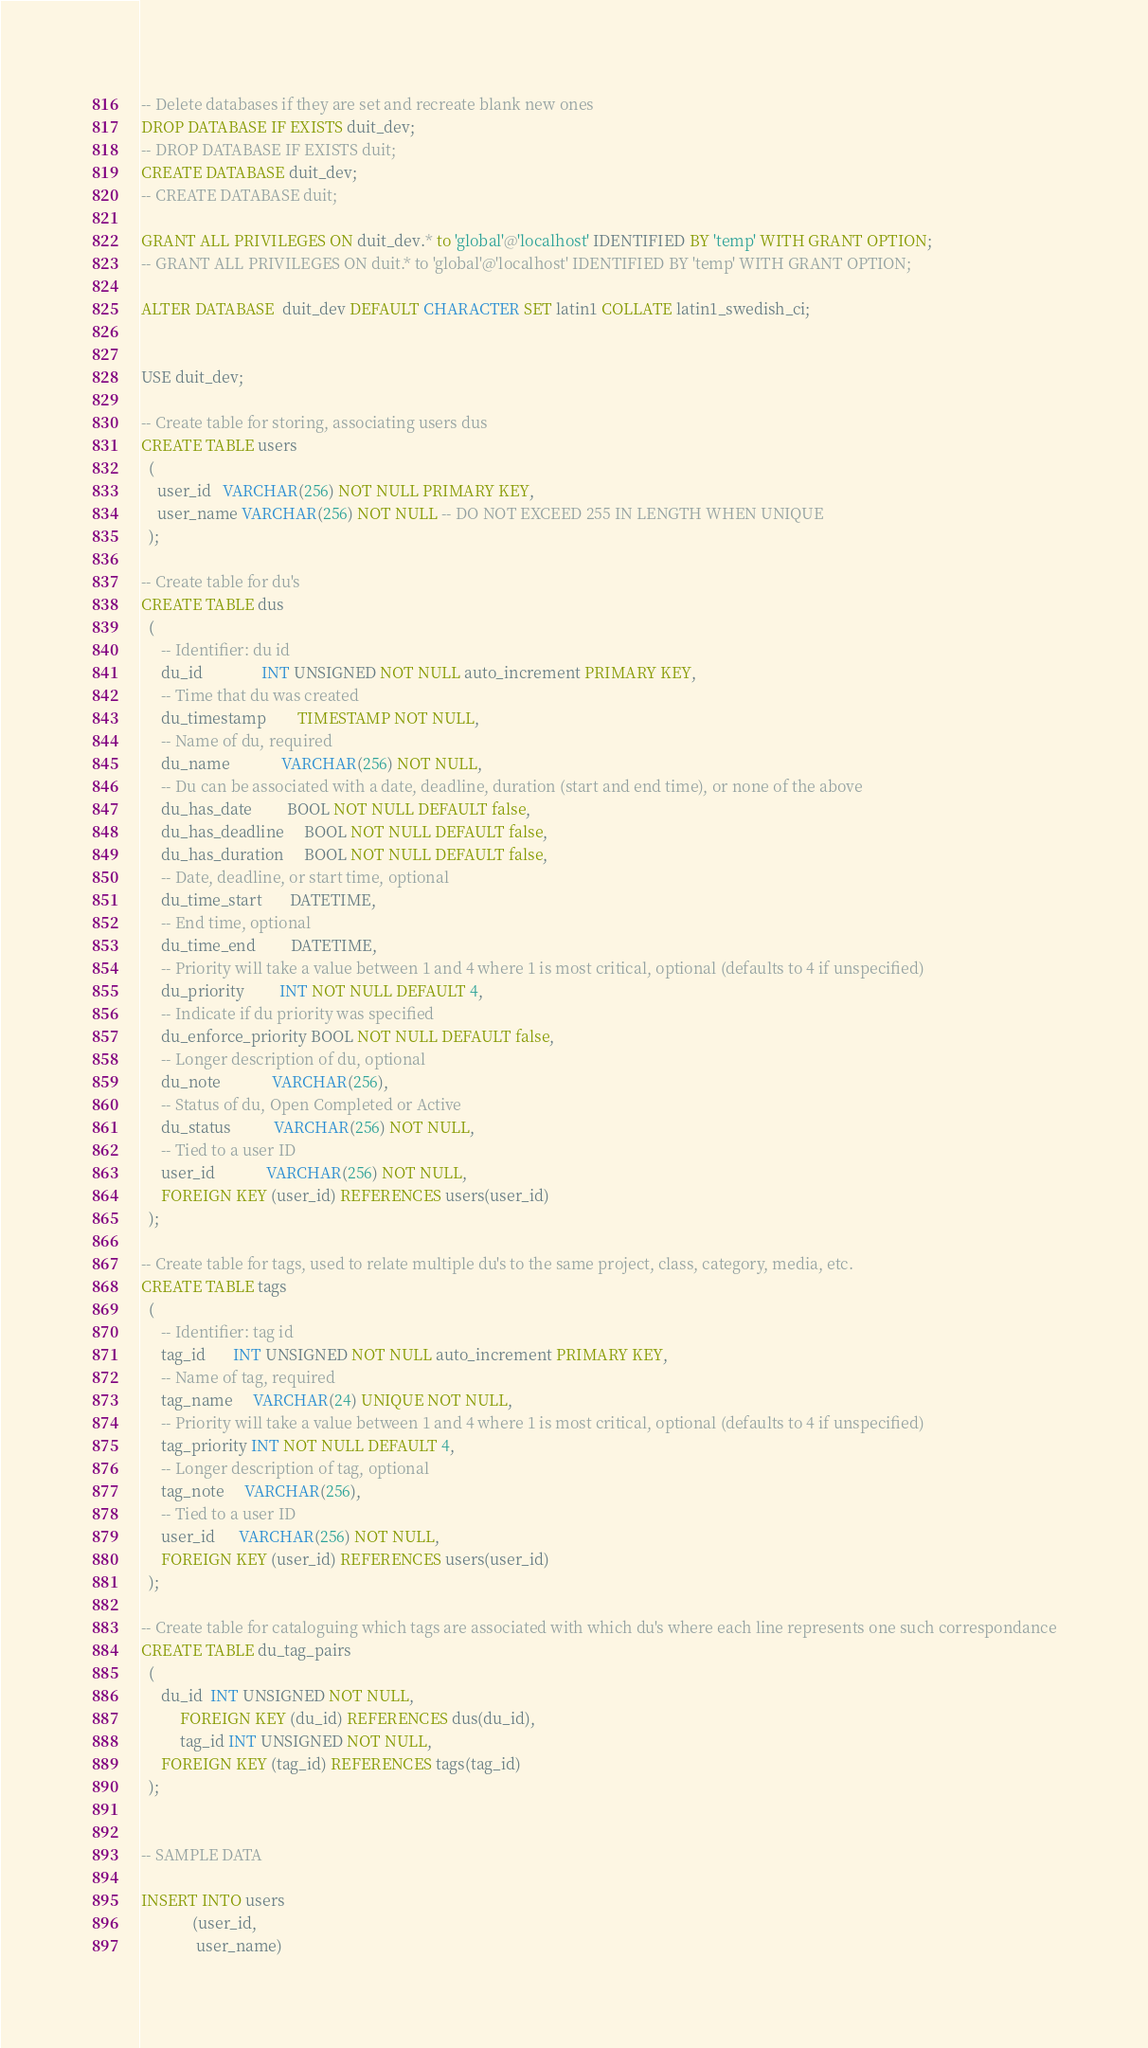<code> <loc_0><loc_0><loc_500><loc_500><_SQL_>-- Delete databases if they are set and recreate blank new ones
DROP DATABASE IF EXISTS duit_dev;
-- DROP DATABASE IF EXISTS duit;
CREATE DATABASE duit_dev;
-- CREATE DATABASE duit;

GRANT ALL PRIVILEGES ON duit_dev.* to 'global'@'localhost' IDENTIFIED BY 'temp' WITH GRANT OPTION;
-- GRANT ALL PRIVILEGES ON duit.* to 'global'@'localhost' IDENTIFIED BY 'temp' WITH GRANT OPTION;

ALTER DATABASE  duit_dev DEFAULT CHARACTER SET latin1 COLLATE latin1_swedish_ci;


USE duit_dev;

-- Create table for storing, associating users dus
CREATE TABLE users
  (
    user_id   VARCHAR(256) NOT NULL PRIMARY KEY,
    user_name VARCHAR(256) NOT NULL -- DO NOT EXCEED 255 IN LENGTH WHEN UNIQUE
  );

-- Create table for du's
CREATE TABLE dus 
  ( 
     -- Identifier: du id 
     du_id               INT UNSIGNED NOT NULL auto_increment PRIMARY KEY, 
     -- Time that du was created 
     du_timestamp        TIMESTAMP NOT NULL, 
     -- Name of du, required 
     du_name             VARCHAR(256) NOT NULL, 
     -- Du can be associated with a date, deadline, duration (start and end time), or none of the above
     du_has_date         BOOL NOT NULL DEFAULT false, 
     du_has_deadline     BOOL NOT NULL DEFAULT false, 
     du_has_duration     BOOL NOT NULL DEFAULT false, 
     -- Date, deadline, or start time, optional 
     du_time_start       DATETIME, 
     -- End time, optional 
     du_time_end         DATETIME, 
     -- Priority will take a value between 1 and 4 where 1 is most critical, optional (defaults to 4 if unspecified)
     du_priority         INT NOT NULL DEFAULT 4, 
     -- Indicate if du priority was specified 
     du_enforce_priority BOOL NOT NULL DEFAULT false, 
     -- Longer description of du, optional 
     du_note             VARCHAR(256),
     -- Status of du, Open Completed or Active
     du_status           VARCHAR(256) NOT NULL,
     -- Tied to a user ID
     user_id             VARCHAR(256) NOT NULL,
     FOREIGN KEY (user_id) REFERENCES users(user_id)
  ); 

-- Create table for tags, used to relate multiple du's to the same project, class, category, media, etc.
CREATE TABLE tags 
  ( 
     -- Identifier: tag id 
     tag_id       INT UNSIGNED NOT NULL auto_increment PRIMARY KEY, 
     -- Name of tag, required 
     tag_name     VARCHAR(24) UNIQUE NOT NULL, 
     -- Priority will take a value between 1 and 4 where 1 is most critical, optional (defaults to 4 if unspecified)
     tag_priority INT NOT NULL DEFAULT 4, 
     -- Longer description of tag, optional 
     tag_note     VARCHAR(256),
     -- Tied to a user ID
     user_id      VARCHAR(256) NOT NULL,
     FOREIGN KEY (user_id) REFERENCES users(user_id)
  );

-- Create table for cataloguing which tags are associated with which du's where each line represents one such correspondance
CREATE TABLE du_tag_pairs 
  ( 
     du_id  INT UNSIGNED NOT NULL, 
          FOREIGN KEY (du_id) REFERENCES dus(du_id), 
          tag_id INT UNSIGNED NOT NULL, 
     FOREIGN KEY (tag_id) REFERENCES tags(tag_id) 
  ); 


-- SAMPLE DATA

INSERT INTO users
             (user_id,
              user_name)</code> 